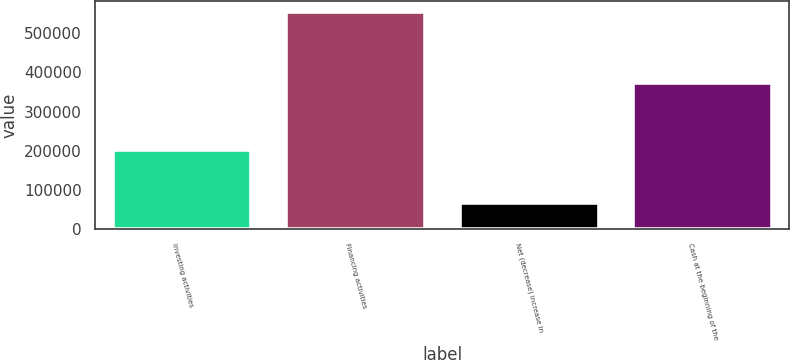Convert chart. <chart><loc_0><loc_0><loc_500><loc_500><bar_chart><fcel>Investing activities<fcel>Financing activities<fcel>Net (decrease) increase in<fcel>Cash at the beginning of the<nl><fcel>203090<fcel>555282<fcel>68010<fcel>373523<nl></chart> 